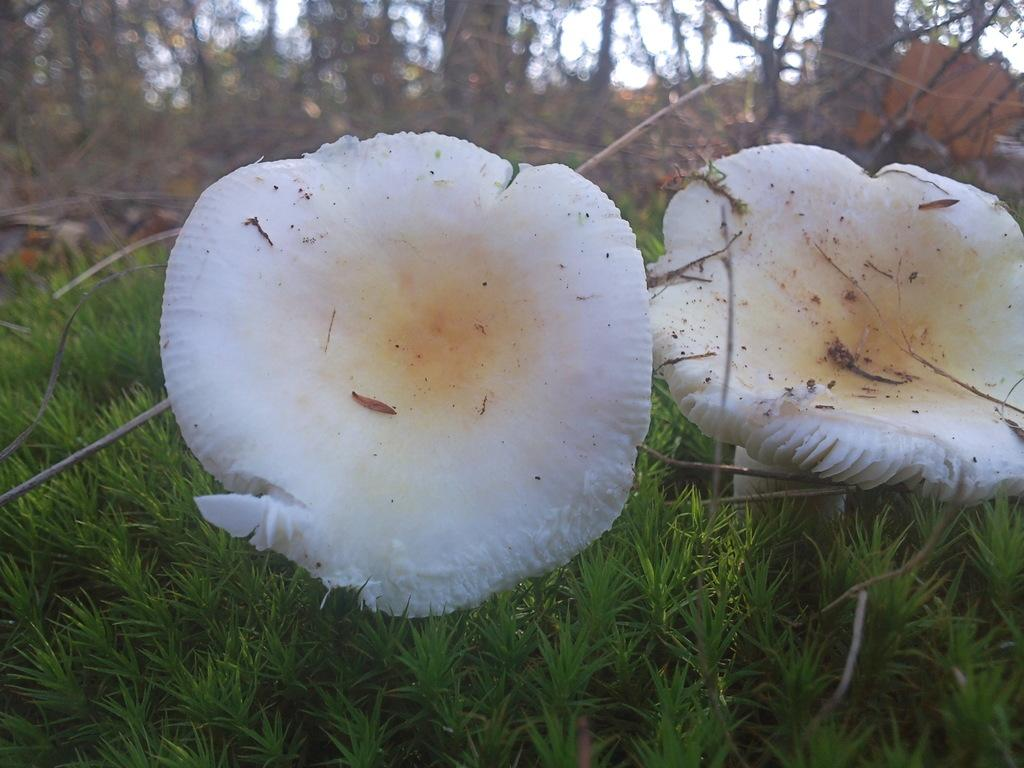What color are the mushrooms in the image? The mushrooms in the image are white. What type of vegetation is on the ground in the image? There is grass on the ground in the image. What can be seen in the background of the image? There are trees in the background of the image. How much respect do the mushrooms show towards the trees in the image? The mushrooms do not show respect or any other emotion in the image, as they are inanimate objects. 